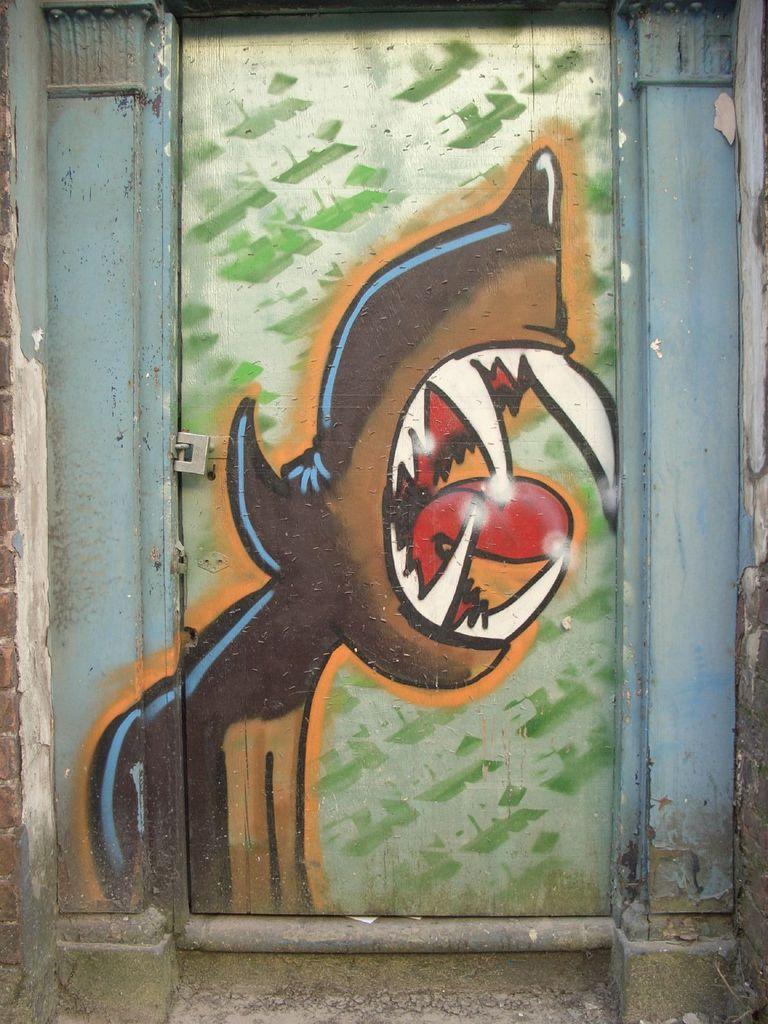Can you describe this image briefly? In the image we can see the painting on the door. 